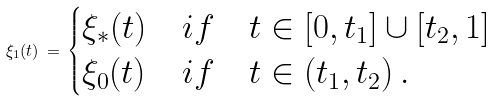<formula> <loc_0><loc_0><loc_500><loc_500>\xi _ { 1 } ( t ) \, = \, \begin{cases} \xi _ { * } ( t ) & i f \quad t \in [ 0 , t _ { 1 } ] \cup [ t _ { 2 } , 1 ] \\ \xi _ { 0 } ( t ) & i f \quad t \in ( t _ { 1 } , t _ { 2 } ) \, . \end{cases}</formula> 